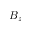Convert formula to latex. <formula><loc_0><loc_0><loc_500><loc_500>B _ { z }</formula> 